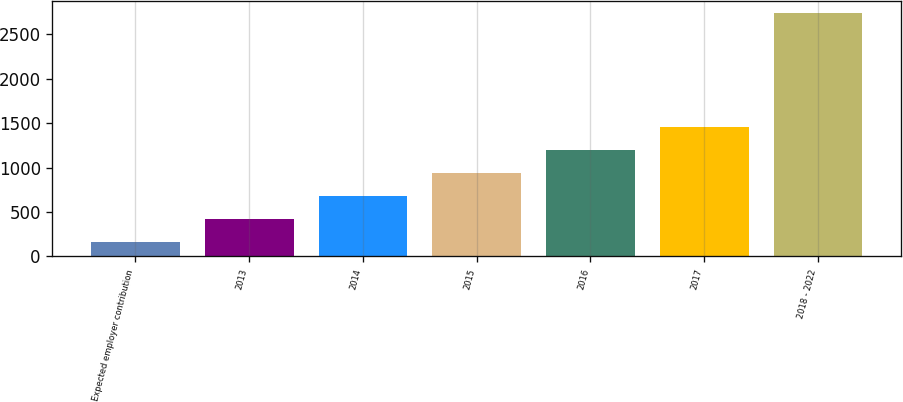Convert chart to OTSL. <chart><loc_0><loc_0><loc_500><loc_500><bar_chart><fcel>Expected employer contribution<fcel>2013<fcel>2014<fcel>2015<fcel>2016<fcel>2017<fcel>2018 - 2022<nl><fcel>165<fcel>425<fcel>682.4<fcel>939.8<fcel>1197.2<fcel>1454.6<fcel>2739<nl></chart> 